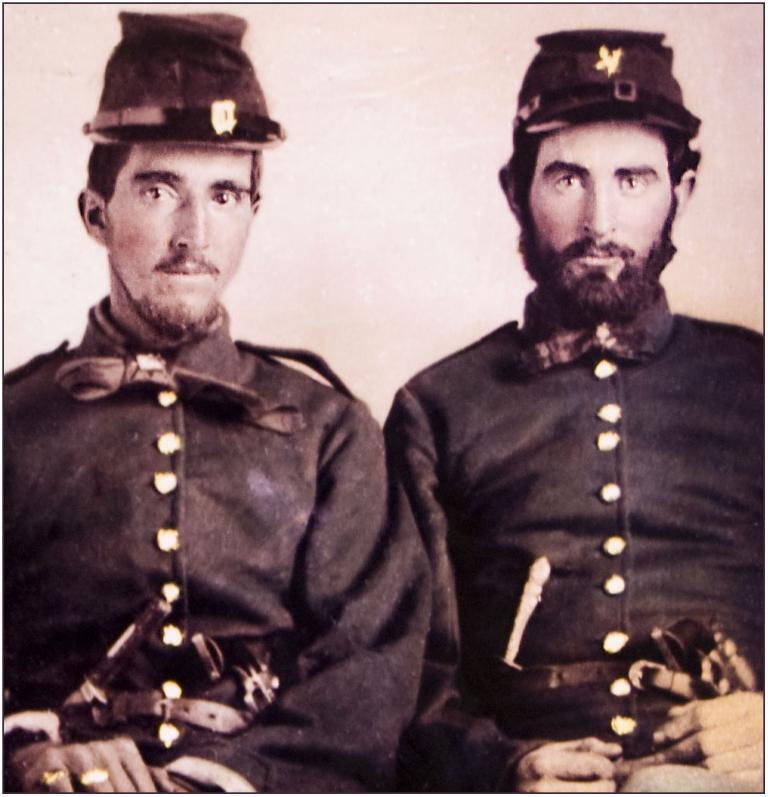In one or two sentences, can you explain what this image depicts? In this picture there are two men wearing the same dress. Both of them are sitting on the chair. At the back there is a wall. 